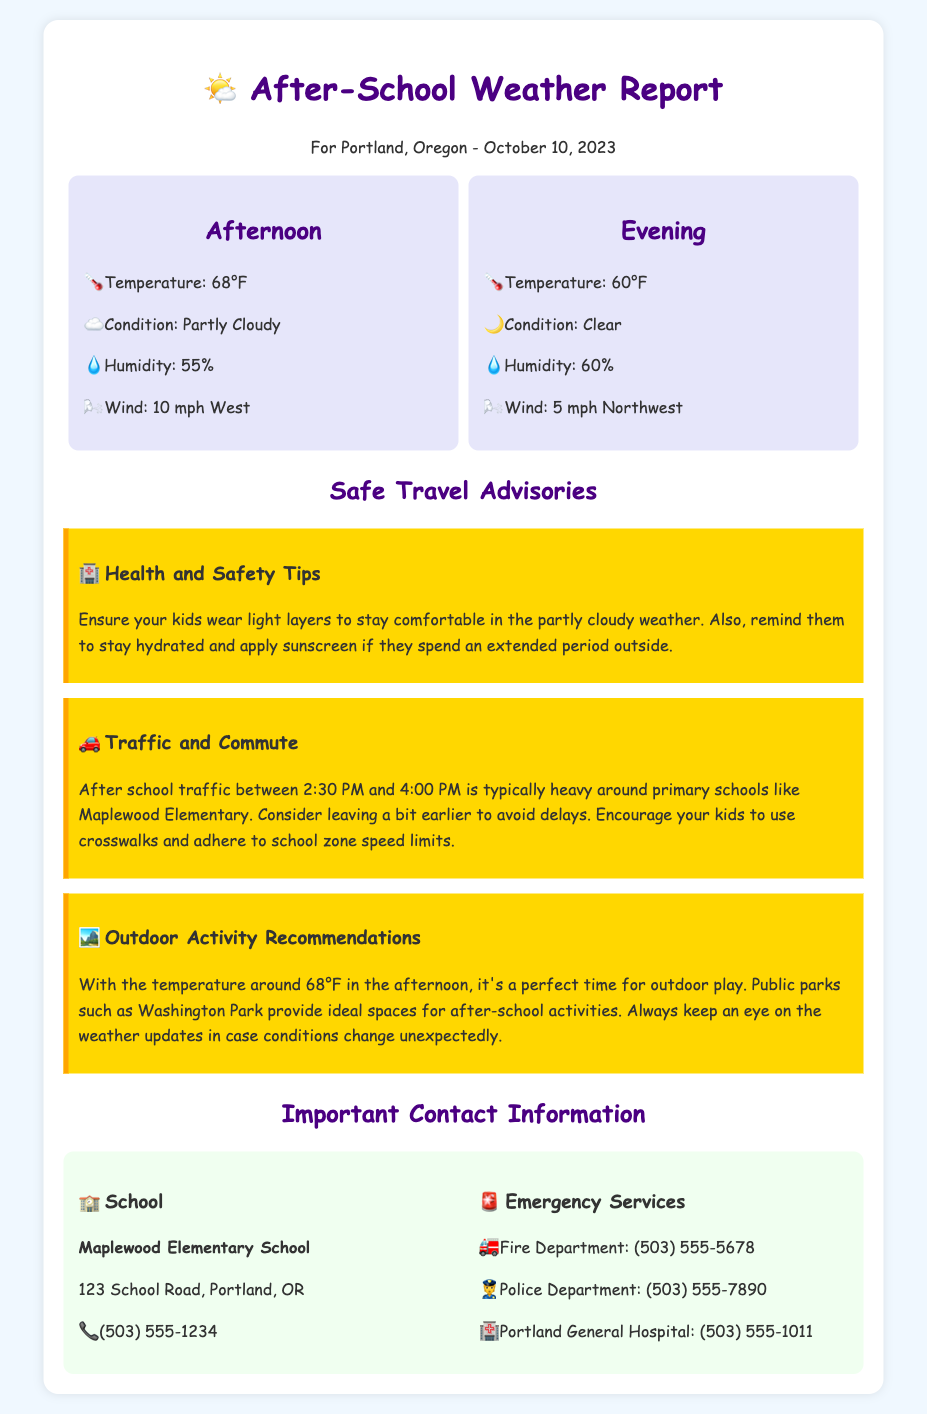What is the temperature in the afternoon? The temperature is listed in the afternoon weather summary of the document, which states it is 68°F.
Answer: 68°F What safety advice is given for outdoor play? The document recommends that kids wear light layers, stay hydrated, and apply sunscreen if they spend extended time outside.
Answer: Wear light layers, stay hydrated, apply sunscreen What is the typical traffic situation after school? The traffic advisory mentions that after school traffic is typically heavy between 2:30 PM and 4:00 PM around primary schools.
Answer: Heavy traffic What is the weather condition in the evening? The evening weather card states the condition is clear and the temperature is 60°F.
Answer: Clear Which park is suggested for outdoor activities? The document suggests Washington Park as an ideal space for after-school activities.
Answer: Washington Park What is the phone number for Maplewood Elementary School? The contact information section of the document provides the phone number for Maplewood Elementary School as (503) 555-1234.
Answer: (503) 555-1234 What should kids use when crossing the street? The traffic advisory specifically advises kids to use crosswalks when commuting.
Answer: Crosswalks What is the humidity level in the afternoon? The weather summary for the afternoon indicates the humidity level is 55%.
Answer: 55% 